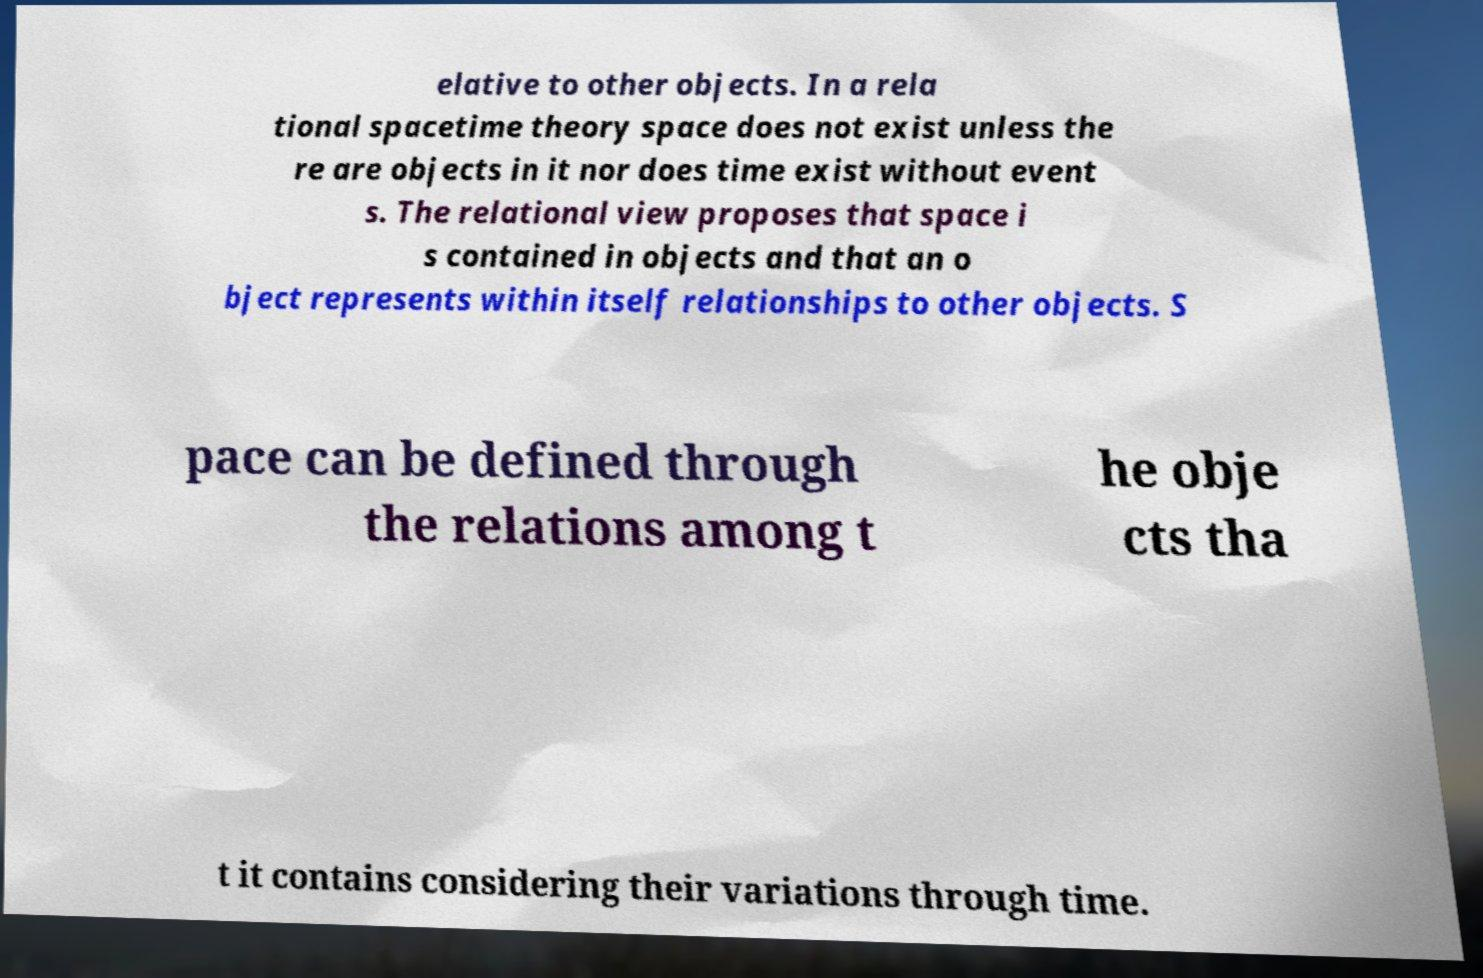Could you extract and type out the text from this image? elative to other objects. In a rela tional spacetime theory space does not exist unless the re are objects in it nor does time exist without event s. The relational view proposes that space i s contained in objects and that an o bject represents within itself relationships to other objects. S pace can be defined through the relations among t he obje cts tha t it contains considering their variations through time. 